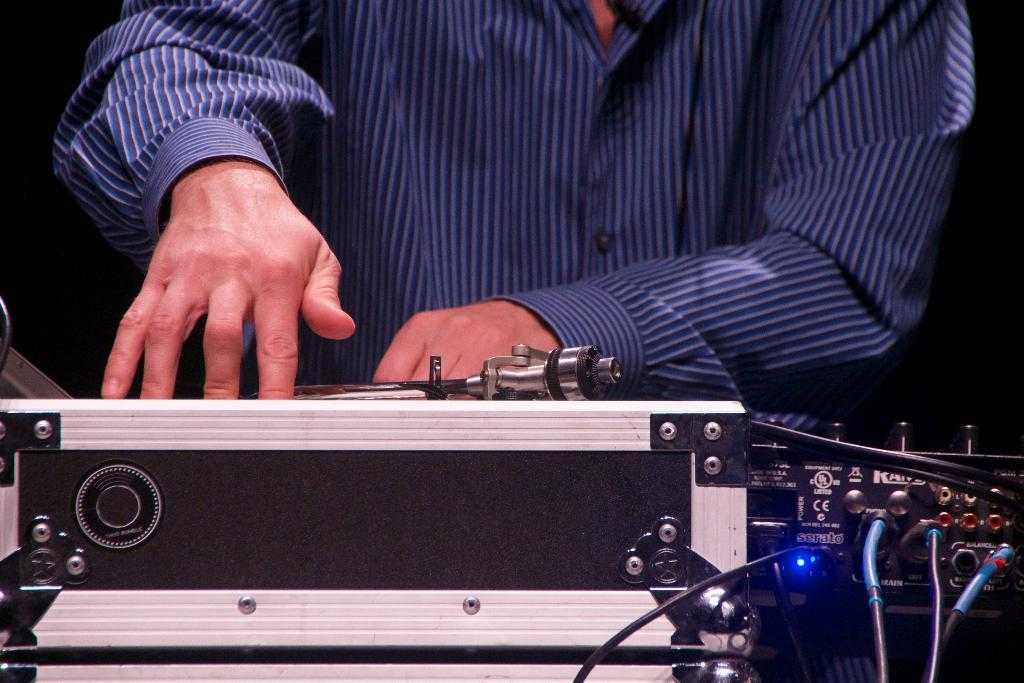What is the person doing in the image? The hands of a person are on an object in the image, suggesting that they are interacting with it. What else can be seen in the image besides the hands? There are wires visible in the image, and there is an electronic device on the right side of the image. What is the color of the background in the image? The background of the image is black in color. What is the weight of the canvas in the image? There is no canvas present in the image, so it is not possible to determine its weight. 